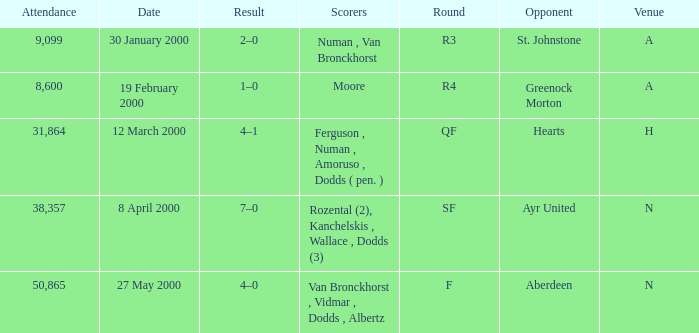Who was in a with opponent St. Johnstone? Numan , Van Bronckhorst. 